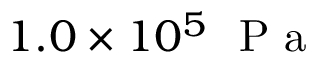Convert formula to latex. <formula><loc_0><loc_0><loc_500><loc_500>1 . 0 \times 1 0 ^ { 5 } P a</formula> 